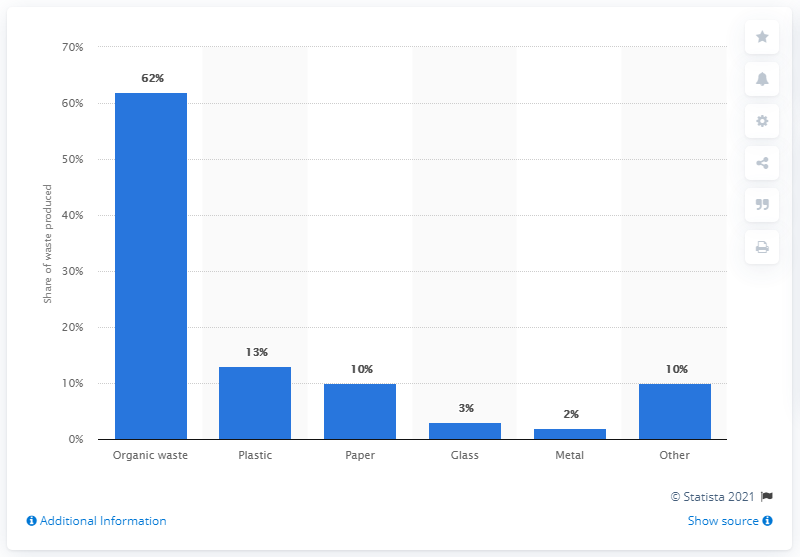Point out several critical features in this image. By 2025, it is forecasted that approximately 13 percent of municipal waste in the East Asia and Pacific regions will be composed of plastic. 